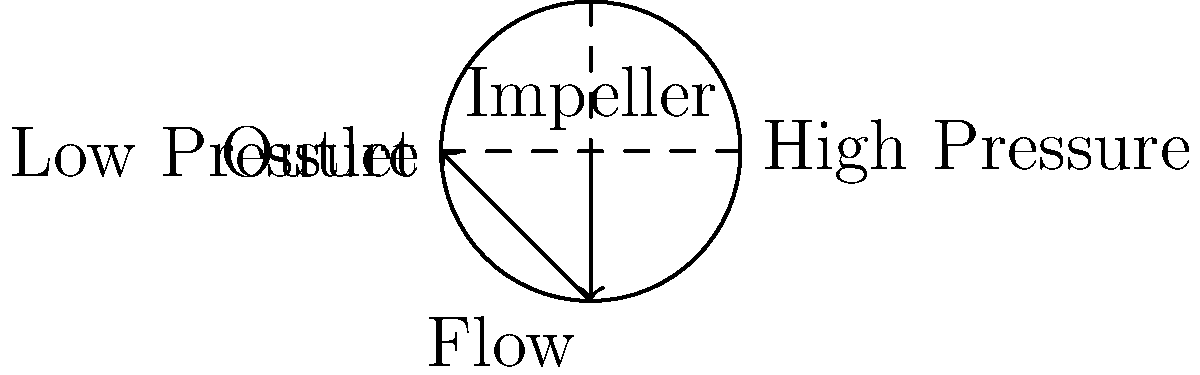In a centrifugal pump, how does the pressure distribution change from the center of the impeller to the outlet, and how does this relate to market competitiveness in the context of digital transformation? To understand the pressure distribution in a centrifugal pump and its relation to market competitiveness, let's break it down step-by-step:

1. Pressure distribution in a centrifugal pump:
   a. At the center of the impeller, the pressure is lowest.
   b. As the fluid moves outward, the pressure increases due to centrifugal force.
   c. The pressure is highest at the pump's outlet.

2. Flow pattern:
   a. Fluid enters at the center of the impeller.
   b. It's then accelerated outward by the rotating impeller blades.
   c. The fluid exits at high velocity at the pump's periphery.

3. Energy conversion:
   a. Mechanical energy from the impeller is converted to kinetic energy in the fluid.
   b. Kinetic energy is then partially converted to pressure energy.

4. Efficiency:
   The efficiency of this energy conversion process is crucial for the pump's performance.

5. Digital transformation impact:
   a. Sensors and IoT devices can monitor pressure distribution in real-time.
   b. Data analytics can optimize pump operation for maximum efficiency.
   c. Predictive maintenance can be implemented based on pressure pattern changes.

6. Market competitiveness:
   a. Improved efficiency leads to lower operating costs.
   b. Real-time monitoring enables quicker response to issues.
   c. Predictive maintenance reduces downtime and extends equipment life.
   d. These factors combined can give companies a competitive edge in the market.

7. Economic implications:
   a. Lower costs can lead to more competitive pricing.
   b. Improved reliability can increase customer satisfaction and market share.
   c. Data-driven insights can inform product development and innovation.

In the context of digital transformation, understanding and optimizing the pressure distribution in centrifugal pumps can significantly impact a company's market competitiveness by reducing costs, improving efficiency, and enabling data-driven decision-making.
Answer: Pressure increases from center to outlet; digital optimization of this process enhances market competitiveness through improved efficiency and data-driven operations. 